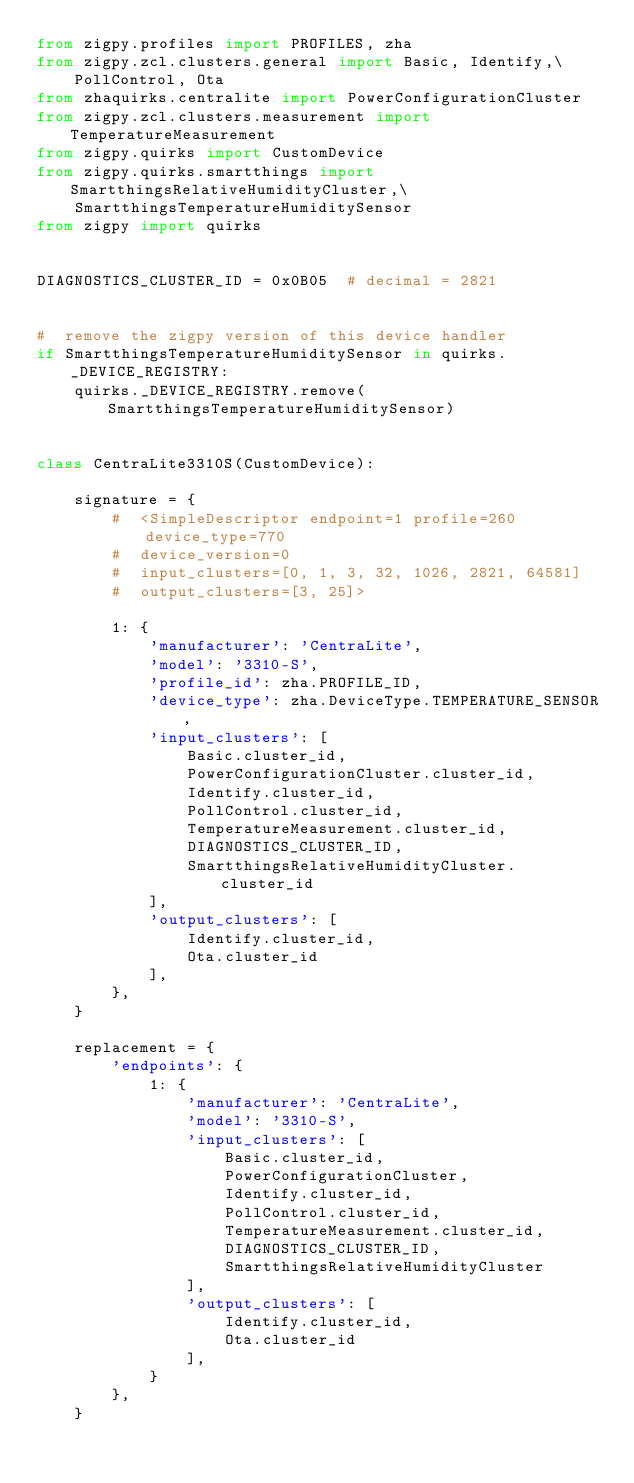<code> <loc_0><loc_0><loc_500><loc_500><_Python_>from zigpy.profiles import PROFILES, zha
from zigpy.zcl.clusters.general import Basic, Identify,\
    PollControl, Ota
from zhaquirks.centralite import PowerConfigurationCluster
from zigpy.zcl.clusters.measurement import TemperatureMeasurement
from zigpy.quirks import CustomDevice
from zigpy.quirks.smartthings import SmartthingsRelativeHumidityCluster,\
    SmartthingsTemperatureHumiditySensor
from zigpy import quirks


DIAGNOSTICS_CLUSTER_ID = 0x0B05  # decimal = 2821


#  remove the zigpy version of this device handler
if SmartthingsTemperatureHumiditySensor in quirks._DEVICE_REGISTRY:
    quirks._DEVICE_REGISTRY.remove(SmartthingsTemperatureHumiditySensor)


class CentraLite3310S(CustomDevice):

    signature = {
        #  <SimpleDescriptor endpoint=1 profile=260 device_type=770
        #  device_version=0
        #  input_clusters=[0, 1, 3, 32, 1026, 2821, 64581]
        #  output_clusters=[3, 25]>

        1: {
            'manufacturer': 'CentraLite',
            'model': '3310-S',
            'profile_id': zha.PROFILE_ID,
            'device_type': zha.DeviceType.TEMPERATURE_SENSOR,
            'input_clusters': [
                Basic.cluster_id,
                PowerConfigurationCluster.cluster_id,
                Identify.cluster_id,
                PollControl.cluster_id,
                TemperatureMeasurement.cluster_id,
                DIAGNOSTICS_CLUSTER_ID,
                SmartthingsRelativeHumidityCluster.cluster_id
            ],
            'output_clusters': [
                Identify.cluster_id,
                Ota.cluster_id
            ],
        },
    }

    replacement = {
        'endpoints': {
            1: {
                'manufacturer': 'CentraLite',
                'model': '3310-S',
                'input_clusters': [
                    Basic.cluster_id,
                    PowerConfigurationCluster,
                    Identify.cluster_id,
                    PollControl.cluster_id,
                    TemperatureMeasurement.cluster_id,
                    DIAGNOSTICS_CLUSTER_ID,
                    SmartthingsRelativeHumidityCluster
                ],
                'output_clusters': [
                    Identify.cluster_id,
                    Ota.cluster_id
                ],
            }
        },
    }
</code> 